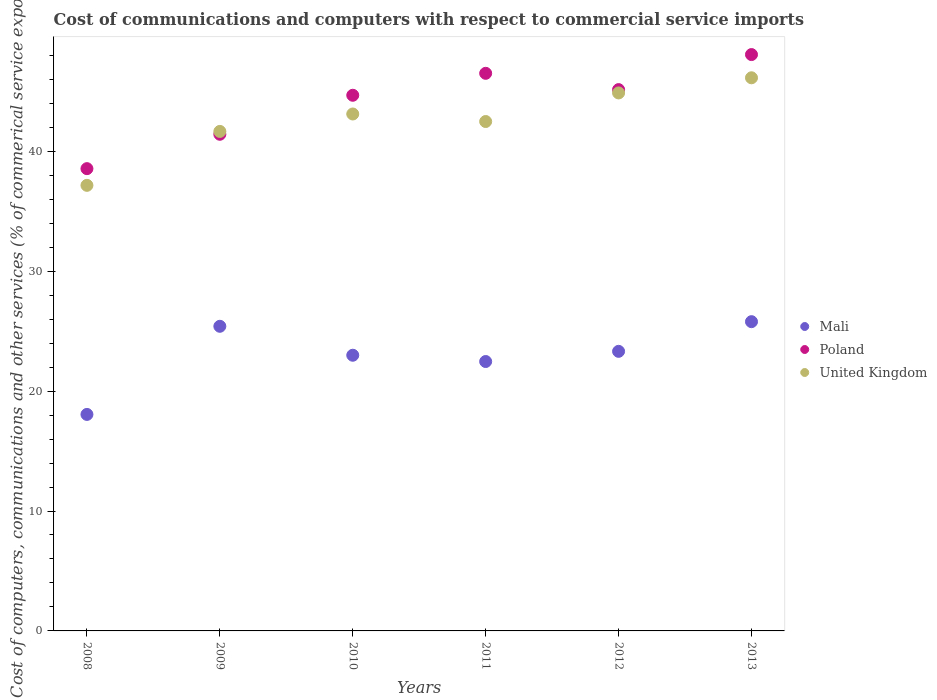How many different coloured dotlines are there?
Your answer should be very brief. 3. What is the cost of communications and computers in United Kingdom in 2012?
Your response must be concise. 44.86. Across all years, what is the maximum cost of communications and computers in United Kingdom?
Keep it short and to the point. 46.12. Across all years, what is the minimum cost of communications and computers in United Kingdom?
Ensure brevity in your answer.  37.16. What is the total cost of communications and computers in Poland in the graph?
Your response must be concise. 264.33. What is the difference between the cost of communications and computers in Poland in 2011 and that in 2012?
Keep it short and to the point. 1.36. What is the difference between the cost of communications and computers in United Kingdom in 2011 and the cost of communications and computers in Mali in 2009?
Keep it short and to the point. 17.08. What is the average cost of communications and computers in Mali per year?
Keep it short and to the point. 23. In the year 2013, what is the difference between the cost of communications and computers in Mali and cost of communications and computers in Poland?
Offer a very short reply. -22.27. In how many years, is the cost of communications and computers in Poland greater than 30 %?
Ensure brevity in your answer.  6. What is the ratio of the cost of communications and computers in Poland in 2010 to that in 2011?
Offer a very short reply. 0.96. Is the difference between the cost of communications and computers in Mali in 2008 and 2011 greater than the difference between the cost of communications and computers in Poland in 2008 and 2011?
Your answer should be compact. Yes. What is the difference between the highest and the second highest cost of communications and computers in Poland?
Your answer should be very brief. 1.56. What is the difference between the highest and the lowest cost of communications and computers in Mali?
Offer a very short reply. 7.73. Is the sum of the cost of communications and computers in United Kingdom in 2009 and 2010 greater than the maximum cost of communications and computers in Mali across all years?
Your answer should be very brief. Yes. How many dotlines are there?
Offer a terse response. 3. Does the graph contain any zero values?
Provide a succinct answer. No. Does the graph contain grids?
Your response must be concise. No. What is the title of the graph?
Make the answer very short. Cost of communications and computers with respect to commercial service imports. Does "Sao Tome and Principe" appear as one of the legend labels in the graph?
Keep it short and to the point. No. What is the label or title of the Y-axis?
Provide a succinct answer. Cost of computers, communications and other services (% of commerical service exports). What is the Cost of computers, communications and other services (% of commerical service exports) of Mali in 2008?
Your answer should be compact. 18.05. What is the Cost of computers, communications and other services (% of commerical service exports) of Poland in 2008?
Your answer should be very brief. 38.55. What is the Cost of computers, communications and other services (% of commerical service exports) of United Kingdom in 2008?
Provide a short and direct response. 37.16. What is the Cost of computers, communications and other services (% of commerical service exports) of Mali in 2009?
Ensure brevity in your answer.  25.4. What is the Cost of computers, communications and other services (% of commerical service exports) of Poland in 2009?
Offer a terse response. 41.41. What is the Cost of computers, communications and other services (% of commerical service exports) of United Kingdom in 2009?
Offer a very short reply. 41.65. What is the Cost of computers, communications and other services (% of commerical service exports) of Mali in 2010?
Offer a terse response. 22.99. What is the Cost of computers, communications and other services (% of commerical service exports) of Poland in 2010?
Provide a short and direct response. 44.67. What is the Cost of computers, communications and other services (% of commerical service exports) of United Kingdom in 2010?
Offer a very short reply. 43.11. What is the Cost of computers, communications and other services (% of commerical service exports) of Mali in 2011?
Provide a succinct answer. 22.47. What is the Cost of computers, communications and other services (% of commerical service exports) of Poland in 2011?
Your response must be concise. 46.5. What is the Cost of computers, communications and other services (% of commerical service exports) in United Kingdom in 2011?
Keep it short and to the point. 42.48. What is the Cost of computers, communications and other services (% of commerical service exports) in Mali in 2012?
Offer a terse response. 23.31. What is the Cost of computers, communications and other services (% of commerical service exports) in Poland in 2012?
Ensure brevity in your answer.  45.14. What is the Cost of computers, communications and other services (% of commerical service exports) of United Kingdom in 2012?
Your answer should be very brief. 44.86. What is the Cost of computers, communications and other services (% of commerical service exports) of Mali in 2013?
Keep it short and to the point. 25.79. What is the Cost of computers, communications and other services (% of commerical service exports) of Poland in 2013?
Provide a succinct answer. 48.06. What is the Cost of computers, communications and other services (% of commerical service exports) in United Kingdom in 2013?
Your answer should be very brief. 46.12. Across all years, what is the maximum Cost of computers, communications and other services (% of commerical service exports) of Mali?
Your response must be concise. 25.79. Across all years, what is the maximum Cost of computers, communications and other services (% of commerical service exports) of Poland?
Keep it short and to the point. 48.06. Across all years, what is the maximum Cost of computers, communications and other services (% of commerical service exports) of United Kingdom?
Make the answer very short. 46.12. Across all years, what is the minimum Cost of computers, communications and other services (% of commerical service exports) in Mali?
Your answer should be compact. 18.05. Across all years, what is the minimum Cost of computers, communications and other services (% of commerical service exports) of Poland?
Ensure brevity in your answer.  38.55. Across all years, what is the minimum Cost of computers, communications and other services (% of commerical service exports) in United Kingdom?
Keep it short and to the point. 37.16. What is the total Cost of computers, communications and other services (% of commerical service exports) in Mali in the graph?
Provide a short and direct response. 138.01. What is the total Cost of computers, communications and other services (% of commerical service exports) of Poland in the graph?
Your answer should be very brief. 264.33. What is the total Cost of computers, communications and other services (% of commerical service exports) of United Kingdom in the graph?
Your answer should be compact. 255.38. What is the difference between the Cost of computers, communications and other services (% of commerical service exports) in Mali in 2008 and that in 2009?
Offer a very short reply. -7.35. What is the difference between the Cost of computers, communications and other services (% of commerical service exports) in Poland in 2008 and that in 2009?
Your answer should be very brief. -2.87. What is the difference between the Cost of computers, communications and other services (% of commerical service exports) in United Kingdom in 2008 and that in 2009?
Offer a terse response. -4.5. What is the difference between the Cost of computers, communications and other services (% of commerical service exports) of Mali in 2008 and that in 2010?
Offer a very short reply. -4.94. What is the difference between the Cost of computers, communications and other services (% of commerical service exports) of Poland in 2008 and that in 2010?
Your response must be concise. -6.12. What is the difference between the Cost of computers, communications and other services (% of commerical service exports) of United Kingdom in 2008 and that in 2010?
Ensure brevity in your answer.  -5.95. What is the difference between the Cost of computers, communications and other services (% of commerical service exports) in Mali in 2008 and that in 2011?
Your response must be concise. -4.41. What is the difference between the Cost of computers, communications and other services (% of commerical service exports) of Poland in 2008 and that in 2011?
Ensure brevity in your answer.  -7.95. What is the difference between the Cost of computers, communications and other services (% of commerical service exports) in United Kingdom in 2008 and that in 2011?
Offer a terse response. -5.32. What is the difference between the Cost of computers, communications and other services (% of commerical service exports) in Mali in 2008 and that in 2012?
Ensure brevity in your answer.  -5.26. What is the difference between the Cost of computers, communications and other services (% of commerical service exports) of Poland in 2008 and that in 2012?
Offer a terse response. -6.59. What is the difference between the Cost of computers, communications and other services (% of commerical service exports) of United Kingdom in 2008 and that in 2012?
Offer a very short reply. -7.71. What is the difference between the Cost of computers, communications and other services (% of commerical service exports) in Mali in 2008 and that in 2013?
Offer a terse response. -7.73. What is the difference between the Cost of computers, communications and other services (% of commerical service exports) in Poland in 2008 and that in 2013?
Make the answer very short. -9.51. What is the difference between the Cost of computers, communications and other services (% of commerical service exports) in United Kingdom in 2008 and that in 2013?
Make the answer very short. -8.97. What is the difference between the Cost of computers, communications and other services (% of commerical service exports) in Mali in 2009 and that in 2010?
Offer a very short reply. 2.41. What is the difference between the Cost of computers, communications and other services (% of commerical service exports) of Poland in 2009 and that in 2010?
Provide a succinct answer. -3.25. What is the difference between the Cost of computers, communications and other services (% of commerical service exports) in United Kingdom in 2009 and that in 2010?
Make the answer very short. -1.45. What is the difference between the Cost of computers, communications and other services (% of commerical service exports) of Mali in 2009 and that in 2011?
Your answer should be very brief. 2.94. What is the difference between the Cost of computers, communications and other services (% of commerical service exports) in Poland in 2009 and that in 2011?
Give a very brief answer. -5.08. What is the difference between the Cost of computers, communications and other services (% of commerical service exports) in United Kingdom in 2009 and that in 2011?
Ensure brevity in your answer.  -0.83. What is the difference between the Cost of computers, communications and other services (% of commerical service exports) of Mali in 2009 and that in 2012?
Provide a short and direct response. 2.09. What is the difference between the Cost of computers, communications and other services (% of commerical service exports) of Poland in 2009 and that in 2012?
Provide a succinct answer. -3.73. What is the difference between the Cost of computers, communications and other services (% of commerical service exports) in United Kingdom in 2009 and that in 2012?
Your answer should be compact. -3.21. What is the difference between the Cost of computers, communications and other services (% of commerical service exports) of Mali in 2009 and that in 2013?
Provide a short and direct response. -0.39. What is the difference between the Cost of computers, communications and other services (% of commerical service exports) of Poland in 2009 and that in 2013?
Your answer should be very brief. -6.65. What is the difference between the Cost of computers, communications and other services (% of commerical service exports) of United Kingdom in 2009 and that in 2013?
Give a very brief answer. -4.47. What is the difference between the Cost of computers, communications and other services (% of commerical service exports) in Mali in 2010 and that in 2011?
Provide a succinct answer. 0.52. What is the difference between the Cost of computers, communications and other services (% of commerical service exports) in Poland in 2010 and that in 2011?
Provide a short and direct response. -1.83. What is the difference between the Cost of computers, communications and other services (% of commerical service exports) of United Kingdom in 2010 and that in 2011?
Your response must be concise. 0.63. What is the difference between the Cost of computers, communications and other services (% of commerical service exports) in Mali in 2010 and that in 2012?
Offer a terse response. -0.33. What is the difference between the Cost of computers, communications and other services (% of commerical service exports) of Poland in 2010 and that in 2012?
Provide a succinct answer. -0.47. What is the difference between the Cost of computers, communications and other services (% of commerical service exports) of United Kingdom in 2010 and that in 2012?
Offer a terse response. -1.76. What is the difference between the Cost of computers, communications and other services (% of commerical service exports) of Mali in 2010 and that in 2013?
Offer a terse response. -2.8. What is the difference between the Cost of computers, communications and other services (% of commerical service exports) of Poland in 2010 and that in 2013?
Offer a very short reply. -3.39. What is the difference between the Cost of computers, communications and other services (% of commerical service exports) in United Kingdom in 2010 and that in 2013?
Your answer should be very brief. -3.02. What is the difference between the Cost of computers, communications and other services (% of commerical service exports) of Mali in 2011 and that in 2012?
Your answer should be compact. -0.85. What is the difference between the Cost of computers, communications and other services (% of commerical service exports) of Poland in 2011 and that in 2012?
Make the answer very short. 1.36. What is the difference between the Cost of computers, communications and other services (% of commerical service exports) in United Kingdom in 2011 and that in 2012?
Provide a short and direct response. -2.38. What is the difference between the Cost of computers, communications and other services (% of commerical service exports) in Mali in 2011 and that in 2013?
Offer a terse response. -3.32. What is the difference between the Cost of computers, communications and other services (% of commerical service exports) in Poland in 2011 and that in 2013?
Offer a very short reply. -1.56. What is the difference between the Cost of computers, communications and other services (% of commerical service exports) in United Kingdom in 2011 and that in 2013?
Give a very brief answer. -3.65. What is the difference between the Cost of computers, communications and other services (% of commerical service exports) in Mali in 2012 and that in 2013?
Ensure brevity in your answer.  -2.47. What is the difference between the Cost of computers, communications and other services (% of commerical service exports) in Poland in 2012 and that in 2013?
Provide a succinct answer. -2.92. What is the difference between the Cost of computers, communications and other services (% of commerical service exports) in United Kingdom in 2012 and that in 2013?
Provide a succinct answer. -1.26. What is the difference between the Cost of computers, communications and other services (% of commerical service exports) in Mali in 2008 and the Cost of computers, communications and other services (% of commerical service exports) in Poland in 2009?
Ensure brevity in your answer.  -23.36. What is the difference between the Cost of computers, communications and other services (% of commerical service exports) in Mali in 2008 and the Cost of computers, communications and other services (% of commerical service exports) in United Kingdom in 2009?
Give a very brief answer. -23.6. What is the difference between the Cost of computers, communications and other services (% of commerical service exports) of Poland in 2008 and the Cost of computers, communications and other services (% of commerical service exports) of United Kingdom in 2009?
Give a very brief answer. -3.1. What is the difference between the Cost of computers, communications and other services (% of commerical service exports) in Mali in 2008 and the Cost of computers, communications and other services (% of commerical service exports) in Poland in 2010?
Keep it short and to the point. -26.61. What is the difference between the Cost of computers, communications and other services (% of commerical service exports) in Mali in 2008 and the Cost of computers, communications and other services (% of commerical service exports) in United Kingdom in 2010?
Give a very brief answer. -25.05. What is the difference between the Cost of computers, communications and other services (% of commerical service exports) in Poland in 2008 and the Cost of computers, communications and other services (% of commerical service exports) in United Kingdom in 2010?
Give a very brief answer. -4.56. What is the difference between the Cost of computers, communications and other services (% of commerical service exports) in Mali in 2008 and the Cost of computers, communications and other services (% of commerical service exports) in Poland in 2011?
Offer a terse response. -28.44. What is the difference between the Cost of computers, communications and other services (% of commerical service exports) in Mali in 2008 and the Cost of computers, communications and other services (% of commerical service exports) in United Kingdom in 2011?
Your answer should be compact. -24.42. What is the difference between the Cost of computers, communications and other services (% of commerical service exports) of Poland in 2008 and the Cost of computers, communications and other services (% of commerical service exports) of United Kingdom in 2011?
Offer a very short reply. -3.93. What is the difference between the Cost of computers, communications and other services (% of commerical service exports) in Mali in 2008 and the Cost of computers, communications and other services (% of commerical service exports) in Poland in 2012?
Make the answer very short. -27.09. What is the difference between the Cost of computers, communications and other services (% of commerical service exports) in Mali in 2008 and the Cost of computers, communications and other services (% of commerical service exports) in United Kingdom in 2012?
Your answer should be compact. -26.81. What is the difference between the Cost of computers, communications and other services (% of commerical service exports) of Poland in 2008 and the Cost of computers, communications and other services (% of commerical service exports) of United Kingdom in 2012?
Your response must be concise. -6.31. What is the difference between the Cost of computers, communications and other services (% of commerical service exports) of Mali in 2008 and the Cost of computers, communications and other services (% of commerical service exports) of Poland in 2013?
Keep it short and to the point. -30.01. What is the difference between the Cost of computers, communications and other services (% of commerical service exports) in Mali in 2008 and the Cost of computers, communications and other services (% of commerical service exports) in United Kingdom in 2013?
Your answer should be very brief. -28.07. What is the difference between the Cost of computers, communications and other services (% of commerical service exports) of Poland in 2008 and the Cost of computers, communications and other services (% of commerical service exports) of United Kingdom in 2013?
Offer a very short reply. -7.58. What is the difference between the Cost of computers, communications and other services (% of commerical service exports) of Mali in 2009 and the Cost of computers, communications and other services (% of commerical service exports) of Poland in 2010?
Your answer should be compact. -19.26. What is the difference between the Cost of computers, communications and other services (% of commerical service exports) of Mali in 2009 and the Cost of computers, communications and other services (% of commerical service exports) of United Kingdom in 2010?
Your answer should be compact. -17.7. What is the difference between the Cost of computers, communications and other services (% of commerical service exports) of Poland in 2009 and the Cost of computers, communications and other services (% of commerical service exports) of United Kingdom in 2010?
Offer a very short reply. -1.69. What is the difference between the Cost of computers, communications and other services (% of commerical service exports) of Mali in 2009 and the Cost of computers, communications and other services (% of commerical service exports) of Poland in 2011?
Ensure brevity in your answer.  -21.1. What is the difference between the Cost of computers, communications and other services (% of commerical service exports) of Mali in 2009 and the Cost of computers, communications and other services (% of commerical service exports) of United Kingdom in 2011?
Offer a very short reply. -17.08. What is the difference between the Cost of computers, communications and other services (% of commerical service exports) in Poland in 2009 and the Cost of computers, communications and other services (% of commerical service exports) in United Kingdom in 2011?
Offer a terse response. -1.06. What is the difference between the Cost of computers, communications and other services (% of commerical service exports) in Mali in 2009 and the Cost of computers, communications and other services (% of commerical service exports) in Poland in 2012?
Offer a very short reply. -19.74. What is the difference between the Cost of computers, communications and other services (% of commerical service exports) of Mali in 2009 and the Cost of computers, communications and other services (% of commerical service exports) of United Kingdom in 2012?
Provide a succinct answer. -19.46. What is the difference between the Cost of computers, communications and other services (% of commerical service exports) in Poland in 2009 and the Cost of computers, communications and other services (% of commerical service exports) in United Kingdom in 2012?
Provide a succinct answer. -3.45. What is the difference between the Cost of computers, communications and other services (% of commerical service exports) in Mali in 2009 and the Cost of computers, communications and other services (% of commerical service exports) in Poland in 2013?
Your response must be concise. -22.66. What is the difference between the Cost of computers, communications and other services (% of commerical service exports) of Mali in 2009 and the Cost of computers, communications and other services (% of commerical service exports) of United Kingdom in 2013?
Offer a very short reply. -20.72. What is the difference between the Cost of computers, communications and other services (% of commerical service exports) of Poland in 2009 and the Cost of computers, communications and other services (% of commerical service exports) of United Kingdom in 2013?
Your answer should be compact. -4.71. What is the difference between the Cost of computers, communications and other services (% of commerical service exports) in Mali in 2010 and the Cost of computers, communications and other services (% of commerical service exports) in Poland in 2011?
Your response must be concise. -23.51. What is the difference between the Cost of computers, communications and other services (% of commerical service exports) of Mali in 2010 and the Cost of computers, communications and other services (% of commerical service exports) of United Kingdom in 2011?
Provide a succinct answer. -19.49. What is the difference between the Cost of computers, communications and other services (% of commerical service exports) of Poland in 2010 and the Cost of computers, communications and other services (% of commerical service exports) of United Kingdom in 2011?
Make the answer very short. 2.19. What is the difference between the Cost of computers, communications and other services (% of commerical service exports) in Mali in 2010 and the Cost of computers, communications and other services (% of commerical service exports) in Poland in 2012?
Your answer should be very brief. -22.15. What is the difference between the Cost of computers, communications and other services (% of commerical service exports) of Mali in 2010 and the Cost of computers, communications and other services (% of commerical service exports) of United Kingdom in 2012?
Provide a succinct answer. -21.87. What is the difference between the Cost of computers, communications and other services (% of commerical service exports) in Poland in 2010 and the Cost of computers, communications and other services (% of commerical service exports) in United Kingdom in 2012?
Your answer should be compact. -0.2. What is the difference between the Cost of computers, communications and other services (% of commerical service exports) in Mali in 2010 and the Cost of computers, communications and other services (% of commerical service exports) in Poland in 2013?
Your answer should be very brief. -25.07. What is the difference between the Cost of computers, communications and other services (% of commerical service exports) in Mali in 2010 and the Cost of computers, communications and other services (% of commerical service exports) in United Kingdom in 2013?
Offer a very short reply. -23.14. What is the difference between the Cost of computers, communications and other services (% of commerical service exports) of Poland in 2010 and the Cost of computers, communications and other services (% of commerical service exports) of United Kingdom in 2013?
Offer a very short reply. -1.46. What is the difference between the Cost of computers, communications and other services (% of commerical service exports) of Mali in 2011 and the Cost of computers, communications and other services (% of commerical service exports) of Poland in 2012?
Ensure brevity in your answer.  -22.67. What is the difference between the Cost of computers, communications and other services (% of commerical service exports) of Mali in 2011 and the Cost of computers, communications and other services (% of commerical service exports) of United Kingdom in 2012?
Provide a short and direct response. -22.4. What is the difference between the Cost of computers, communications and other services (% of commerical service exports) of Poland in 2011 and the Cost of computers, communications and other services (% of commerical service exports) of United Kingdom in 2012?
Give a very brief answer. 1.64. What is the difference between the Cost of computers, communications and other services (% of commerical service exports) of Mali in 2011 and the Cost of computers, communications and other services (% of commerical service exports) of Poland in 2013?
Your answer should be very brief. -25.6. What is the difference between the Cost of computers, communications and other services (% of commerical service exports) in Mali in 2011 and the Cost of computers, communications and other services (% of commerical service exports) in United Kingdom in 2013?
Your response must be concise. -23.66. What is the difference between the Cost of computers, communications and other services (% of commerical service exports) in Poland in 2011 and the Cost of computers, communications and other services (% of commerical service exports) in United Kingdom in 2013?
Your answer should be compact. 0.37. What is the difference between the Cost of computers, communications and other services (% of commerical service exports) in Mali in 2012 and the Cost of computers, communications and other services (% of commerical service exports) in Poland in 2013?
Keep it short and to the point. -24.75. What is the difference between the Cost of computers, communications and other services (% of commerical service exports) in Mali in 2012 and the Cost of computers, communications and other services (% of commerical service exports) in United Kingdom in 2013?
Offer a very short reply. -22.81. What is the difference between the Cost of computers, communications and other services (% of commerical service exports) of Poland in 2012 and the Cost of computers, communications and other services (% of commerical service exports) of United Kingdom in 2013?
Your answer should be compact. -0.98. What is the average Cost of computers, communications and other services (% of commerical service exports) in Mali per year?
Your answer should be very brief. 23. What is the average Cost of computers, communications and other services (% of commerical service exports) of Poland per year?
Give a very brief answer. 44.05. What is the average Cost of computers, communications and other services (% of commerical service exports) of United Kingdom per year?
Provide a short and direct response. 42.56. In the year 2008, what is the difference between the Cost of computers, communications and other services (% of commerical service exports) of Mali and Cost of computers, communications and other services (% of commerical service exports) of Poland?
Keep it short and to the point. -20.49. In the year 2008, what is the difference between the Cost of computers, communications and other services (% of commerical service exports) of Mali and Cost of computers, communications and other services (% of commerical service exports) of United Kingdom?
Give a very brief answer. -19.1. In the year 2008, what is the difference between the Cost of computers, communications and other services (% of commerical service exports) of Poland and Cost of computers, communications and other services (% of commerical service exports) of United Kingdom?
Your response must be concise. 1.39. In the year 2009, what is the difference between the Cost of computers, communications and other services (% of commerical service exports) in Mali and Cost of computers, communications and other services (% of commerical service exports) in Poland?
Keep it short and to the point. -16.01. In the year 2009, what is the difference between the Cost of computers, communications and other services (% of commerical service exports) in Mali and Cost of computers, communications and other services (% of commerical service exports) in United Kingdom?
Make the answer very short. -16.25. In the year 2009, what is the difference between the Cost of computers, communications and other services (% of commerical service exports) of Poland and Cost of computers, communications and other services (% of commerical service exports) of United Kingdom?
Your answer should be compact. -0.24. In the year 2010, what is the difference between the Cost of computers, communications and other services (% of commerical service exports) of Mali and Cost of computers, communications and other services (% of commerical service exports) of Poland?
Provide a short and direct response. -21.68. In the year 2010, what is the difference between the Cost of computers, communications and other services (% of commerical service exports) of Mali and Cost of computers, communications and other services (% of commerical service exports) of United Kingdom?
Make the answer very short. -20.12. In the year 2010, what is the difference between the Cost of computers, communications and other services (% of commerical service exports) in Poland and Cost of computers, communications and other services (% of commerical service exports) in United Kingdom?
Make the answer very short. 1.56. In the year 2011, what is the difference between the Cost of computers, communications and other services (% of commerical service exports) in Mali and Cost of computers, communications and other services (% of commerical service exports) in Poland?
Provide a short and direct response. -24.03. In the year 2011, what is the difference between the Cost of computers, communications and other services (% of commerical service exports) of Mali and Cost of computers, communications and other services (% of commerical service exports) of United Kingdom?
Your answer should be very brief. -20.01. In the year 2011, what is the difference between the Cost of computers, communications and other services (% of commerical service exports) of Poland and Cost of computers, communications and other services (% of commerical service exports) of United Kingdom?
Provide a short and direct response. 4.02. In the year 2012, what is the difference between the Cost of computers, communications and other services (% of commerical service exports) in Mali and Cost of computers, communications and other services (% of commerical service exports) in Poland?
Make the answer very short. -21.83. In the year 2012, what is the difference between the Cost of computers, communications and other services (% of commerical service exports) of Mali and Cost of computers, communications and other services (% of commerical service exports) of United Kingdom?
Keep it short and to the point. -21.55. In the year 2012, what is the difference between the Cost of computers, communications and other services (% of commerical service exports) in Poland and Cost of computers, communications and other services (% of commerical service exports) in United Kingdom?
Keep it short and to the point. 0.28. In the year 2013, what is the difference between the Cost of computers, communications and other services (% of commerical service exports) in Mali and Cost of computers, communications and other services (% of commerical service exports) in Poland?
Provide a succinct answer. -22.27. In the year 2013, what is the difference between the Cost of computers, communications and other services (% of commerical service exports) in Mali and Cost of computers, communications and other services (% of commerical service exports) in United Kingdom?
Give a very brief answer. -20.34. In the year 2013, what is the difference between the Cost of computers, communications and other services (% of commerical service exports) in Poland and Cost of computers, communications and other services (% of commerical service exports) in United Kingdom?
Provide a short and direct response. 1.94. What is the ratio of the Cost of computers, communications and other services (% of commerical service exports) of Mali in 2008 to that in 2009?
Offer a terse response. 0.71. What is the ratio of the Cost of computers, communications and other services (% of commerical service exports) of Poland in 2008 to that in 2009?
Offer a terse response. 0.93. What is the ratio of the Cost of computers, communications and other services (% of commerical service exports) in United Kingdom in 2008 to that in 2009?
Your answer should be very brief. 0.89. What is the ratio of the Cost of computers, communications and other services (% of commerical service exports) in Mali in 2008 to that in 2010?
Make the answer very short. 0.79. What is the ratio of the Cost of computers, communications and other services (% of commerical service exports) in Poland in 2008 to that in 2010?
Provide a short and direct response. 0.86. What is the ratio of the Cost of computers, communications and other services (% of commerical service exports) in United Kingdom in 2008 to that in 2010?
Ensure brevity in your answer.  0.86. What is the ratio of the Cost of computers, communications and other services (% of commerical service exports) in Mali in 2008 to that in 2011?
Make the answer very short. 0.8. What is the ratio of the Cost of computers, communications and other services (% of commerical service exports) of Poland in 2008 to that in 2011?
Ensure brevity in your answer.  0.83. What is the ratio of the Cost of computers, communications and other services (% of commerical service exports) in United Kingdom in 2008 to that in 2011?
Offer a very short reply. 0.87. What is the ratio of the Cost of computers, communications and other services (% of commerical service exports) in Mali in 2008 to that in 2012?
Offer a very short reply. 0.77. What is the ratio of the Cost of computers, communications and other services (% of commerical service exports) in Poland in 2008 to that in 2012?
Your answer should be compact. 0.85. What is the ratio of the Cost of computers, communications and other services (% of commerical service exports) in United Kingdom in 2008 to that in 2012?
Give a very brief answer. 0.83. What is the ratio of the Cost of computers, communications and other services (% of commerical service exports) in Mali in 2008 to that in 2013?
Give a very brief answer. 0.7. What is the ratio of the Cost of computers, communications and other services (% of commerical service exports) of Poland in 2008 to that in 2013?
Provide a succinct answer. 0.8. What is the ratio of the Cost of computers, communications and other services (% of commerical service exports) of United Kingdom in 2008 to that in 2013?
Offer a very short reply. 0.81. What is the ratio of the Cost of computers, communications and other services (% of commerical service exports) of Mali in 2009 to that in 2010?
Your answer should be compact. 1.1. What is the ratio of the Cost of computers, communications and other services (% of commerical service exports) of Poland in 2009 to that in 2010?
Provide a short and direct response. 0.93. What is the ratio of the Cost of computers, communications and other services (% of commerical service exports) of United Kingdom in 2009 to that in 2010?
Your answer should be compact. 0.97. What is the ratio of the Cost of computers, communications and other services (% of commerical service exports) of Mali in 2009 to that in 2011?
Your answer should be very brief. 1.13. What is the ratio of the Cost of computers, communications and other services (% of commerical service exports) in Poland in 2009 to that in 2011?
Your response must be concise. 0.89. What is the ratio of the Cost of computers, communications and other services (% of commerical service exports) in United Kingdom in 2009 to that in 2011?
Keep it short and to the point. 0.98. What is the ratio of the Cost of computers, communications and other services (% of commerical service exports) in Mali in 2009 to that in 2012?
Provide a short and direct response. 1.09. What is the ratio of the Cost of computers, communications and other services (% of commerical service exports) of Poland in 2009 to that in 2012?
Offer a very short reply. 0.92. What is the ratio of the Cost of computers, communications and other services (% of commerical service exports) in United Kingdom in 2009 to that in 2012?
Give a very brief answer. 0.93. What is the ratio of the Cost of computers, communications and other services (% of commerical service exports) in Mali in 2009 to that in 2013?
Offer a terse response. 0.98. What is the ratio of the Cost of computers, communications and other services (% of commerical service exports) of Poland in 2009 to that in 2013?
Your answer should be compact. 0.86. What is the ratio of the Cost of computers, communications and other services (% of commerical service exports) in United Kingdom in 2009 to that in 2013?
Provide a succinct answer. 0.9. What is the ratio of the Cost of computers, communications and other services (% of commerical service exports) of Mali in 2010 to that in 2011?
Your answer should be compact. 1.02. What is the ratio of the Cost of computers, communications and other services (% of commerical service exports) of Poland in 2010 to that in 2011?
Offer a terse response. 0.96. What is the ratio of the Cost of computers, communications and other services (% of commerical service exports) of United Kingdom in 2010 to that in 2011?
Ensure brevity in your answer.  1.01. What is the ratio of the Cost of computers, communications and other services (% of commerical service exports) of Mali in 2010 to that in 2012?
Provide a succinct answer. 0.99. What is the ratio of the Cost of computers, communications and other services (% of commerical service exports) in United Kingdom in 2010 to that in 2012?
Provide a short and direct response. 0.96. What is the ratio of the Cost of computers, communications and other services (% of commerical service exports) in Mali in 2010 to that in 2013?
Your answer should be very brief. 0.89. What is the ratio of the Cost of computers, communications and other services (% of commerical service exports) in Poland in 2010 to that in 2013?
Ensure brevity in your answer.  0.93. What is the ratio of the Cost of computers, communications and other services (% of commerical service exports) of United Kingdom in 2010 to that in 2013?
Give a very brief answer. 0.93. What is the ratio of the Cost of computers, communications and other services (% of commerical service exports) of Mali in 2011 to that in 2012?
Give a very brief answer. 0.96. What is the ratio of the Cost of computers, communications and other services (% of commerical service exports) in Poland in 2011 to that in 2012?
Your response must be concise. 1.03. What is the ratio of the Cost of computers, communications and other services (% of commerical service exports) of United Kingdom in 2011 to that in 2012?
Ensure brevity in your answer.  0.95. What is the ratio of the Cost of computers, communications and other services (% of commerical service exports) in Mali in 2011 to that in 2013?
Your response must be concise. 0.87. What is the ratio of the Cost of computers, communications and other services (% of commerical service exports) of Poland in 2011 to that in 2013?
Give a very brief answer. 0.97. What is the ratio of the Cost of computers, communications and other services (% of commerical service exports) of United Kingdom in 2011 to that in 2013?
Give a very brief answer. 0.92. What is the ratio of the Cost of computers, communications and other services (% of commerical service exports) of Mali in 2012 to that in 2013?
Make the answer very short. 0.9. What is the ratio of the Cost of computers, communications and other services (% of commerical service exports) of Poland in 2012 to that in 2013?
Make the answer very short. 0.94. What is the ratio of the Cost of computers, communications and other services (% of commerical service exports) in United Kingdom in 2012 to that in 2013?
Provide a short and direct response. 0.97. What is the difference between the highest and the second highest Cost of computers, communications and other services (% of commerical service exports) in Mali?
Your answer should be very brief. 0.39. What is the difference between the highest and the second highest Cost of computers, communications and other services (% of commerical service exports) of Poland?
Keep it short and to the point. 1.56. What is the difference between the highest and the second highest Cost of computers, communications and other services (% of commerical service exports) of United Kingdom?
Make the answer very short. 1.26. What is the difference between the highest and the lowest Cost of computers, communications and other services (% of commerical service exports) of Mali?
Ensure brevity in your answer.  7.73. What is the difference between the highest and the lowest Cost of computers, communications and other services (% of commerical service exports) in Poland?
Offer a terse response. 9.51. What is the difference between the highest and the lowest Cost of computers, communications and other services (% of commerical service exports) of United Kingdom?
Your answer should be very brief. 8.97. 